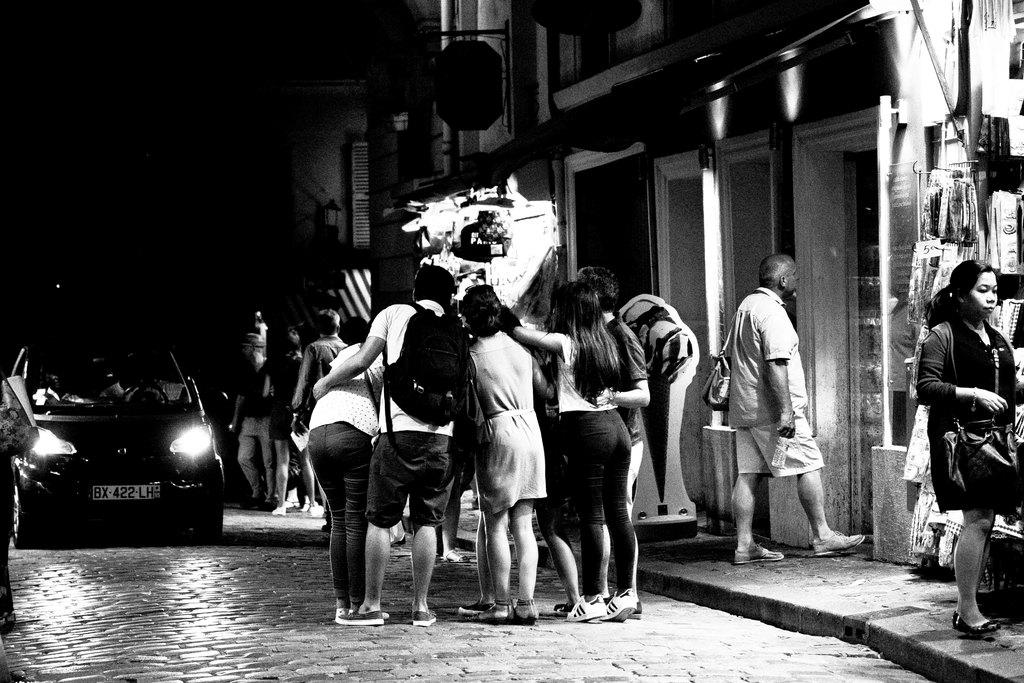How many people are in the image? There is a group of people in the image, but the exact number is not specified. What are the people doing in the image? The people are standing beside a building. Can you describe the building in the image? The provided facts do not give any details about the building. What else can be seen in the image besides the people and the building? There is a car visible in the image. What type of wound can be seen on the car in the image? There is no wound visible on the car in the image. What song is being sung by the people in the image? The provided facts do not mention any singing or music in the image. 